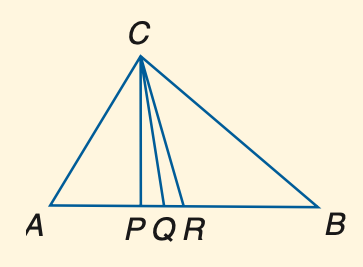Question: In the figure, C P is an altitude, C Q is the angle bisector of \angle A C B, and R is the midpoint of A B. Find A B if A R = 3 x + 6 and R B = 5 x - 14.
Choices:
A. 66
B. 68
C. 70
D. 72
Answer with the letter. Answer: D Question: In the figure, C P is an altitude, C Q is the angle bisector of \angle A C B, and R is the midpoint of A B. Find x if m \angle A P C = 72 + x.
Choices:
A. 12
B. 15
C. 16
D. 18
Answer with the letter. Answer: D 